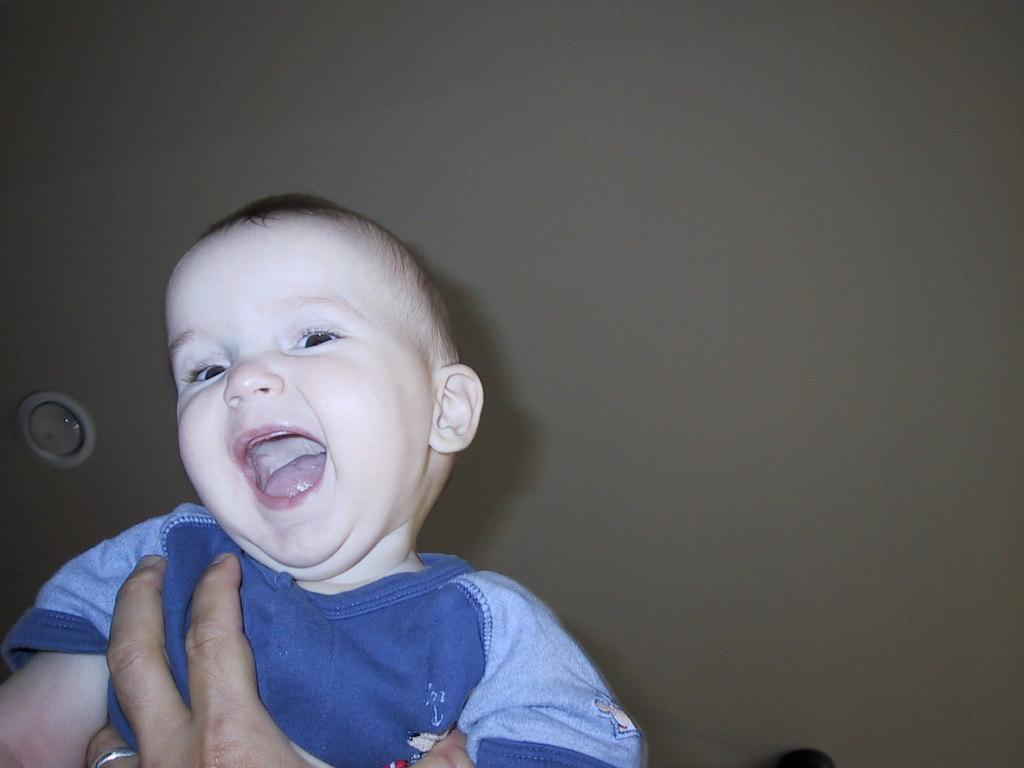What is the main subject of the image? The main subject of the image is a kid. What is the kid wearing in the image? The kid is wearing a blue t-shirt in the image. What is the kid's facial expression in the image? The kid is smiling in the image. What is the kid doing with his hand in the image? The kid has a hand in front of him in the image. Where is the scene of the image located? The scene is above a ceiling in the image. What type of stage is visible in the image? There is no stage present in the image. How many different sorts of existence can be seen in the image? The concept of existence is not applicable to the image, as it features a kid in a specific setting. 